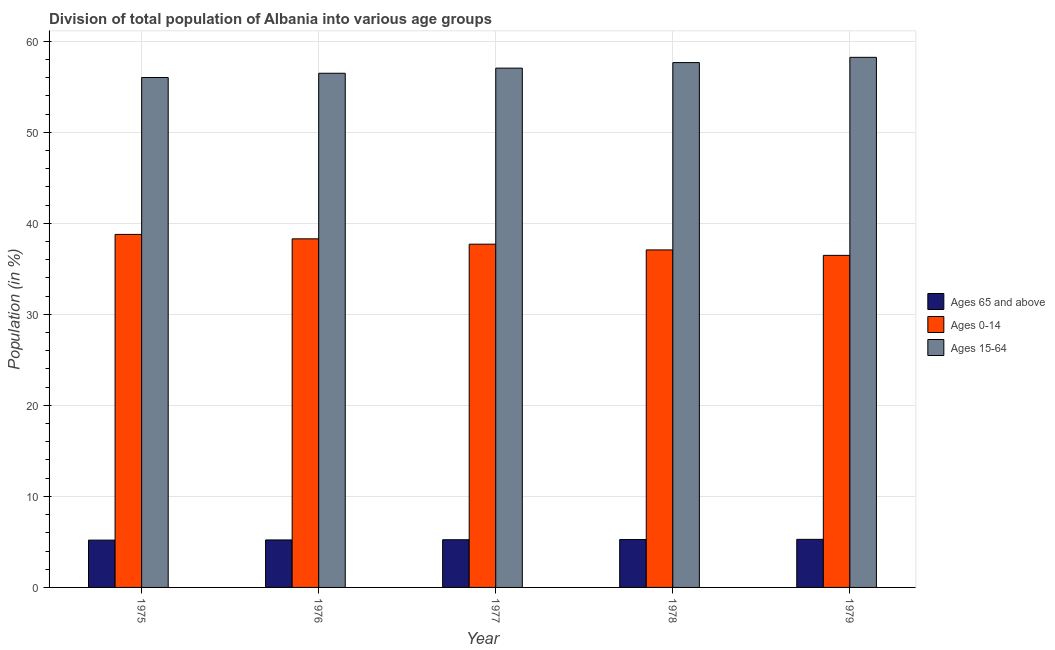How many groups of bars are there?
Your answer should be compact. 5. Are the number of bars on each tick of the X-axis equal?
Your answer should be compact. Yes. What is the label of the 3rd group of bars from the left?
Make the answer very short. 1977. In how many cases, is the number of bars for a given year not equal to the number of legend labels?
Provide a succinct answer. 0. What is the percentage of population within the age-group 15-64 in 1976?
Your answer should be compact. 56.49. Across all years, what is the maximum percentage of population within the age-group 15-64?
Give a very brief answer. 58.24. Across all years, what is the minimum percentage of population within the age-group 0-14?
Your answer should be very brief. 36.48. In which year was the percentage of population within the age-group 0-14 maximum?
Ensure brevity in your answer.  1975. In which year was the percentage of population within the age-group 0-14 minimum?
Give a very brief answer. 1979. What is the total percentage of population within the age-group 0-14 in the graph?
Offer a terse response. 188.35. What is the difference between the percentage of population within the age-group 15-64 in 1977 and that in 1978?
Provide a short and direct response. -0.61. What is the difference between the percentage of population within the age-group 0-14 in 1978 and the percentage of population within the age-group 15-64 in 1979?
Keep it short and to the point. 0.6. What is the average percentage of population within the age-group 15-64 per year?
Provide a succinct answer. 57.09. In the year 1976, what is the difference between the percentage of population within the age-group 0-14 and percentage of population within the age-group 15-64?
Provide a short and direct response. 0. In how many years, is the percentage of population within the age-group 0-14 greater than 40 %?
Make the answer very short. 0. What is the ratio of the percentage of population within the age-group 0-14 in 1976 to that in 1977?
Give a very brief answer. 1.02. Is the percentage of population within the age-group 0-14 in 1975 less than that in 1978?
Provide a succinct answer. No. Is the difference between the percentage of population within the age-group 15-64 in 1975 and 1976 greater than the difference between the percentage of population within the age-group of 65 and above in 1975 and 1976?
Provide a succinct answer. No. What is the difference between the highest and the second highest percentage of population within the age-group of 65 and above?
Provide a succinct answer. 0.02. What is the difference between the highest and the lowest percentage of population within the age-group 0-14?
Your answer should be compact. 2.3. Is the sum of the percentage of population within the age-group of 65 and above in 1976 and 1978 greater than the maximum percentage of population within the age-group 15-64 across all years?
Your answer should be compact. Yes. What does the 3rd bar from the left in 1978 represents?
Provide a succinct answer. Ages 15-64. What does the 3rd bar from the right in 1976 represents?
Offer a terse response. Ages 65 and above. Is it the case that in every year, the sum of the percentage of population within the age-group of 65 and above and percentage of population within the age-group 0-14 is greater than the percentage of population within the age-group 15-64?
Offer a very short reply. No. How many bars are there?
Keep it short and to the point. 15. Are all the bars in the graph horizontal?
Ensure brevity in your answer.  No. How many years are there in the graph?
Provide a succinct answer. 5. What is the difference between two consecutive major ticks on the Y-axis?
Keep it short and to the point. 10. Are the values on the major ticks of Y-axis written in scientific E-notation?
Your answer should be very brief. No. Where does the legend appear in the graph?
Offer a very short reply. Center right. How many legend labels are there?
Provide a succinct answer. 3. What is the title of the graph?
Make the answer very short. Division of total population of Albania into various age groups
. Does "Non-communicable diseases" appear as one of the legend labels in the graph?
Offer a terse response. No. What is the label or title of the Y-axis?
Provide a short and direct response. Population (in %). What is the Population (in %) in Ages 65 and above in 1975?
Offer a terse response. 5.2. What is the Population (in %) of Ages 0-14 in 1975?
Offer a terse response. 38.78. What is the Population (in %) in Ages 15-64 in 1975?
Provide a succinct answer. 56.02. What is the Population (in %) in Ages 65 and above in 1976?
Offer a terse response. 5.22. What is the Population (in %) of Ages 0-14 in 1976?
Your answer should be very brief. 38.3. What is the Population (in %) in Ages 15-64 in 1976?
Offer a terse response. 56.49. What is the Population (in %) in Ages 65 and above in 1977?
Give a very brief answer. 5.24. What is the Population (in %) in Ages 0-14 in 1977?
Make the answer very short. 37.71. What is the Population (in %) in Ages 15-64 in 1977?
Ensure brevity in your answer.  57.05. What is the Population (in %) in Ages 65 and above in 1978?
Your response must be concise. 5.26. What is the Population (in %) in Ages 0-14 in 1978?
Your answer should be very brief. 37.08. What is the Population (in %) in Ages 15-64 in 1978?
Provide a short and direct response. 57.66. What is the Population (in %) in Ages 65 and above in 1979?
Ensure brevity in your answer.  5.28. What is the Population (in %) of Ages 0-14 in 1979?
Offer a terse response. 36.48. What is the Population (in %) in Ages 15-64 in 1979?
Offer a very short reply. 58.24. Across all years, what is the maximum Population (in %) in Ages 65 and above?
Keep it short and to the point. 5.28. Across all years, what is the maximum Population (in %) of Ages 0-14?
Provide a succinct answer. 38.78. Across all years, what is the maximum Population (in %) of Ages 15-64?
Give a very brief answer. 58.24. Across all years, what is the minimum Population (in %) in Ages 65 and above?
Provide a succinct answer. 5.2. Across all years, what is the minimum Population (in %) in Ages 0-14?
Keep it short and to the point. 36.48. Across all years, what is the minimum Population (in %) of Ages 15-64?
Offer a very short reply. 56.02. What is the total Population (in %) of Ages 65 and above in the graph?
Offer a terse response. 26.19. What is the total Population (in %) in Ages 0-14 in the graph?
Provide a short and direct response. 188.35. What is the total Population (in %) in Ages 15-64 in the graph?
Provide a short and direct response. 285.45. What is the difference between the Population (in %) in Ages 65 and above in 1975 and that in 1976?
Make the answer very short. -0.02. What is the difference between the Population (in %) of Ages 0-14 in 1975 and that in 1976?
Keep it short and to the point. 0.49. What is the difference between the Population (in %) in Ages 15-64 in 1975 and that in 1976?
Give a very brief answer. -0.47. What is the difference between the Population (in %) in Ages 65 and above in 1975 and that in 1977?
Make the answer very short. -0.04. What is the difference between the Population (in %) in Ages 0-14 in 1975 and that in 1977?
Make the answer very short. 1.07. What is the difference between the Population (in %) of Ages 15-64 in 1975 and that in 1977?
Keep it short and to the point. -1.03. What is the difference between the Population (in %) in Ages 65 and above in 1975 and that in 1978?
Make the answer very short. -0.06. What is the difference between the Population (in %) in Ages 0-14 in 1975 and that in 1978?
Offer a terse response. 1.7. What is the difference between the Population (in %) of Ages 15-64 in 1975 and that in 1978?
Your response must be concise. -1.64. What is the difference between the Population (in %) in Ages 65 and above in 1975 and that in 1979?
Your answer should be very brief. -0.08. What is the difference between the Population (in %) of Ages 0-14 in 1975 and that in 1979?
Make the answer very short. 2.3. What is the difference between the Population (in %) of Ages 15-64 in 1975 and that in 1979?
Your answer should be compact. -2.22. What is the difference between the Population (in %) in Ages 65 and above in 1976 and that in 1977?
Make the answer very short. -0.02. What is the difference between the Population (in %) in Ages 0-14 in 1976 and that in 1977?
Give a very brief answer. 0.59. What is the difference between the Population (in %) of Ages 15-64 in 1976 and that in 1977?
Provide a succinct answer. -0.56. What is the difference between the Population (in %) of Ages 65 and above in 1976 and that in 1978?
Give a very brief answer. -0.04. What is the difference between the Population (in %) in Ages 0-14 in 1976 and that in 1978?
Offer a terse response. 1.22. What is the difference between the Population (in %) of Ages 15-64 in 1976 and that in 1978?
Keep it short and to the point. -1.17. What is the difference between the Population (in %) of Ages 65 and above in 1976 and that in 1979?
Provide a succinct answer. -0.06. What is the difference between the Population (in %) in Ages 0-14 in 1976 and that in 1979?
Provide a succinct answer. 1.81. What is the difference between the Population (in %) in Ages 15-64 in 1976 and that in 1979?
Your response must be concise. -1.75. What is the difference between the Population (in %) in Ages 65 and above in 1977 and that in 1978?
Ensure brevity in your answer.  -0.02. What is the difference between the Population (in %) of Ages 0-14 in 1977 and that in 1978?
Your answer should be very brief. 0.63. What is the difference between the Population (in %) in Ages 15-64 in 1977 and that in 1978?
Offer a terse response. -0.61. What is the difference between the Population (in %) of Ages 65 and above in 1977 and that in 1979?
Offer a terse response. -0.04. What is the difference between the Population (in %) in Ages 0-14 in 1977 and that in 1979?
Make the answer very short. 1.23. What is the difference between the Population (in %) in Ages 15-64 in 1977 and that in 1979?
Offer a very short reply. -1.19. What is the difference between the Population (in %) in Ages 65 and above in 1978 and that in 1979?
Provide a short and direct response. -0.02. What is the difference between the Population (in %) of Ages 0-14 in 1978 and that in 1979?
Make the answer very short. 0.6. What is the difference between the Population (in %) of Ages 15-64 in 1978 and that in 1979?
Your answer should be very brief. -0.58. What is the difference between the Population (in %) of Ages 65 and above in 1975 and the Population (in %) of Ages 0-14 in 1976?
Your response must be concise. -33.1. What is the difference between the Population (in %) of Ages 65 and above in 1975 and the Population (in %) of Ages 15-64 in 1976?
Provide a short and direct response. -51.29. What is the difference between the Population (in %) of Ages 0-14 in 1975 and the Population (in %) of Ages 15-64 in 1976?
Offer a terse response. -17.7. What is the difference between the Population (in %) of Ages 65 and above in 1975 and the Population (in %) of Ages 0-14 in 1977?
Your answer should be compact. -32.51. What is the difference between the Population (in %) in Ages 65 and above in 1975 and the Population (in %) in Ages 15-64 in 1977?
Keep it short and to the point. -51.85. What is the difference between the Population (in %) in Ages 0-14 in 1975 and the Population (in %) in Ages 15-64 in 1977?
Your answer should be very brief. -18.27. What is the difference between the Population (in %) of Ages 65 and above in 1975 and the Population (in %) of Ages 0-14 in 1978?
Make the answer very short. -31.88. What is the difference between the Population (in %) in Ages 65 and above in 1975 and the Population (in %) in Ages 15-64 in 1978?
Provide a short and direct response. -52.46. What is the difference between the Population (in %) in Ages 0-14 in 1975 and the Population (in %) in Ages 15-64 in 1978?
Your answer should be very brief. -18.87. What is the difference between the Population (in %) in Ages 65 and above in 1975 and the Population (in %) in Ages 0-14 in 1979?
Offer a terse response. -31.28. What is the difference between the Population (in %) in Ages 65 and above in 1975 and the Population (in %) in Ages 15-64 in 1979?
Provide a short and direct response. -53.04. What is the difference between the Population (in %) in Ages 0-14 in 1975 and the Population (in %) in Ages 15-64 in 1979?
Provide a short and direct response. -19.45. What is the difference between the Population (in %) of Ages 65 and above in 1976 and the Population (in %) of Ages 0-14 in 1977?
Offer a very short reply. -32.49. What is the difference between the Population (in %) of Ages 65 and above in 1976 and the Population (in %) of Ages 15-64 in 1977?
Ensure brevity in your answer.  -51.83. What is the difference between the Population (in %) of Ages 0-14 in 1976 and the Population (in %) of Ages 15-64 in 1977?
Make the answer very short. -18.76. What is the difference between the Population (in %) in Ages 65 and above in 1976 and the Population (in %) in Ages 0-14 in 1978?
Keep it short and to the point. -31.86. What is the difference between the Population (in %) of Ages 65 and above in 1976 and the Population (in %) of Ages 15-64 in 1978?
Ensure brevity in your answer.  -52.44. What is the difference between the Population (in %) of Ages 0-14 in 1976 and the Population (in %) of Ages 15-64 in 1978?
Your response must be concise. -19.36. What is the difference between the Population (in %) of Ages 65 and above in 1976 and the Population (in %) of Ages 0-14 in 1979?
Give a very brief answer. -31.26. What is the difference between the Population (in %) in Ages 65 and above in 1976 and the Population (in %) in Ages 15-64 in 1979?
Your answer should be compact. -53.02. What is the difference between the Population (in %) in Ages 0-14 in 1976 and the Population (in %) in Ages 15-64 in 1979?
Offer a terse response. -19.94. What is the difference between the Population (in %) of Ages 65 and above in 1977 and the Population (in %) of Ages 0-14 in 1978?
Your response must be concise. -31.84. What is the difference between the Population (in %) in Ages 65 and above in 1977 and the Population (in %) in Ages 15-64 in 1978?
Keep it short and to the point. -52.42. What is the difference between the Population (in %) of Ages 0-14 in 1977 and the Population (in %) of Ages 15-64 in 1978?
Provide a succinct answer. -19.95. What is the difference between the Population (in %) of Ages 65 and above in 1977 and the Population (in %) of Ages 0-14 in 1979?
Offer a terse response. -31.24. What is the difference between the Population (in %) of Ages 65 and above in 1977 and the Population (in %) of Ages 15-64 in 1979?
Your answer should be very brief. -53. What is the difference between the Population (in %) in Ages 0-14 in 1977 and the Population (in %) in Ages 15-64 in 1979?
Keep it short and to the point. -20.53. What is the difference between the Population (in %) of Ages 65 and above in 1978 and the Population (in %) of Ages 0-14 in 1979?
Make the answer very short. -31.22. What is the difference between the Population (in %) of Ages 65 and above in 1978 and the Population (in %) of Ages 15-64 in 1979?
Offer a terse response. -52.98. What is the difference between the Population (in %) of Ages 0-14 in 1978 and the Population (in %) of Ages 15-64 in 1979?
Provide a short and direct response. -21.16. What is the average Population (in %) of Ages 65 and above per year?
Your response must be concise. 5.24. What is the average Population (in %) of Ages 0-14 per year?
Your answer should be compact. 37.67. What is the average Population (in %) of Ages 15-64 per year?
Keep it short and to the point. 57.09. In the year 1975, what is the difference between the Population (in %) of Ages 65 and above and Population (in %) of Ages 0-14?
Make the answer very short. -33.59. In the year 1975, what is the difference between the Population (in %) in Ages 65 and above and Population (in %) in Ages 15-64?
Your answer should be compact. -50.82. In the year 1975, what is the difference between the Population (in %) of Ages 0-14 and Population (in %) of Ages 15-64?
Your answer should be very brief. -17.23. In the year 1976, what is the difference between the Population (in %) of Ages 65 and above and Population (in %) of Ages 0-14?
Provide a succinct answer. -33.08. In the year 1976, what is the difference between the Population (in %) of Ages 65 and above and Population (in %) of Ages 15-64?
Provide a succinct answer. -51.27. In the year 1976, what is the difference between the Population (in %) in Ages 0-14 and Population (in %) in Ages 15-64?
Your answer should be compact. -18.19. In the year 1977, what is the difference between the Population (in %) of Ages 65 and above and Population (in %) of Ages 0-14?
Offer a terse response. -32.47. In the year 1977, what is the difference between the Population (in %) in Ages 65 and above and Population (in %) in Ages 15-64?
Provide a short and direct response. -51.81. In the year 1977, what is the difference between the Population (in %) of Ages 0-14 and Population (in %) of Ages 15-64?
Offer a very short reply. -19.34. In the year 1978, what is the difference between the Population (in %) of Ages 65 and above and Population (in %) of Ages 0-14?
Offer a very short reply. -31.82. In the year 1978, what is the difference between the Population (in %) in Ages 65 and above and Population (in %) in Ages 15-64?
Offer a very short reply. -52.4. In the year 1978, what is the difference between the Population (in %) in Ages 0-14 and Population (in %) in Ages 15-64?
Offer a very short reply. -20.58. In the year 1979, what is the difference between the Population (in %) of Ages 65 and above and Population (in %) of Ages 0-14?
Provide a succinct answer. -31.2. In the year 1979, what is the difference between the Population (in %) of Ages 65 and above and Population (in %) of Ages 15-64?
Provide a short and direct response. -52.96. In the year 1979, what is the difference between the Population (in %) of Ages 0-14 and Population (in %) of Ages 15-64?
Offer a very short reply. -21.76. What is the ratio of the Population (in %) in Ages 65 and above in 1975 to that in 1976?
Your response must be concise. 1. What is the ratio of the Population (in %) of Ages 0-14 in 1975 to that in 1976?
Offer a very short reply. 1.01. What is the ratio of the Population (in %) of Ages 15-64 in 1975 to that in 1976?
Ensure brevity in your answer.  0.99. What is the ratio of the Population (in %) of Ages 65 and above in 1975 to that in 1977?
Make the answer very short. 0.99. What is the ratio of the Population (in %) in Ages 0-14 in 1975 to that in 1977?
Offer a terse response. 1.03. What is the ratio of the Population (in %) of Ages 15-64 in 1975 to that in 1977?
Your answer should be compact. 0.98. What is the ratio of the Population (in %) of Ages 65 and above in 1975 to that in 1978?
Your answer should be compact. 0.99. What is the ratio of the Population (in %) of Ages 0-14 in 1975 to that in 1978?
Offer a terse response. 1.05. What is the ratio of the Population (in %) of Ages 15-64 in 1975 to that in 1978?
Your answer should be compact. 0.97. What is the ratio of the Population (in %) of Ages 0-14 in 1975 to that in 1979?
Provide a succinct answer. 1.06. What is the ratio of the Population (in %) of Ages 15-64 in 1975 to that in 1979?
Ensure brevity in your answer.  0.96. What is the ratio of the Population (in %) of Ages 65 and above in 1976 to that in 1977?
Provide a short and direct response. 1. What is the ratio of the Population (in %) in Ages 0-14 in 1976 to that in 1977?
Offer a very short reply. 1.02. What is the ratio of the Population (in %) of Ages 0-14 in 1976 to that in 1978?
Offer a very short reply. 1.03. What is the ratio of the Population (in %) of Ages 15-64 in 1976 to that in 1978?
Your answer should be compact. 0.98. What is the ratio of the Population (in %) of Ages 0-14 in 1976 to that in 1979?
Offer a very short reply. 1.05. What is the ratio of the Population (in %) of Ages 15-64 in 1976 to that in 1979?
Your response must be concise. 0.97. What is the ratio of the Population (in %) in Ages 65 and above in 1977 to that in 1978?
Offer a very short reply. 1. What is the ratio of the Population (in %) in Ages 15-64 in 1977 to that in 1978?
Provide a succinct answer. 0.99. What is the ratio of the Population (in %) of Ages 0-14 in 1977 to that in 1979?
Keep it short and to the point. 1.03. What is the ratio of the Population (in %) in Ages 15-64 in 1977 to that in 1979?
Provide a succinct answer. 0.98. What is the ratio of the Population (in %) in Ages 0-14 in 1978 to that in 1979?
Offer a terse response. 1.02. What is the ratio of the Population (in %) in Ages 15-64 in 1978 to that in 1979?
Offer a terse response. 0.99. What is the difference between the highest and the second highest Population (in %) of Ages 65 and above?
Give a very brief answer. 0.02. What is the difference between the highest and the second highest Population (in %) in Ages 0-14?
Give a very brief answer. 0.49. What is the difference between the highest and the second highest Population (in %) in Ages 15-64?
Your answer should be very brief. 0.58. What is the difference between the highest and the lowest Population (in %) in Ages 65 and above?
Provide a succinct answer. 0.08. What is the difference between the highest and the lowest Population (in %) of Ages 0-14?
Your response must be concise. 2.3. What is the difference between the highest and the lowest Population (in %) of Ages 15-64?
Keep it short and to the point. 2.22. 